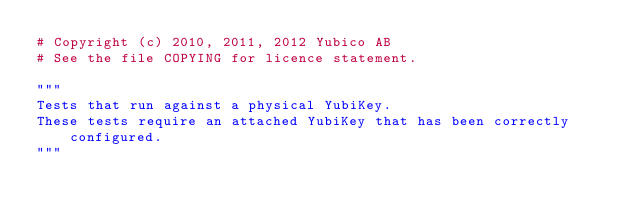Convert code to text. <code><loc_0><loc_0><loc_500><loc_500><_Python_># Copyright (c) 2010, 2011, 2012 Yubico AB
# See the file COPYING for licence statement.

"""
Tests that run against a physical YubiKey.
These tests require an attached YubiKey that has been correctly configured.
"""
</code> 